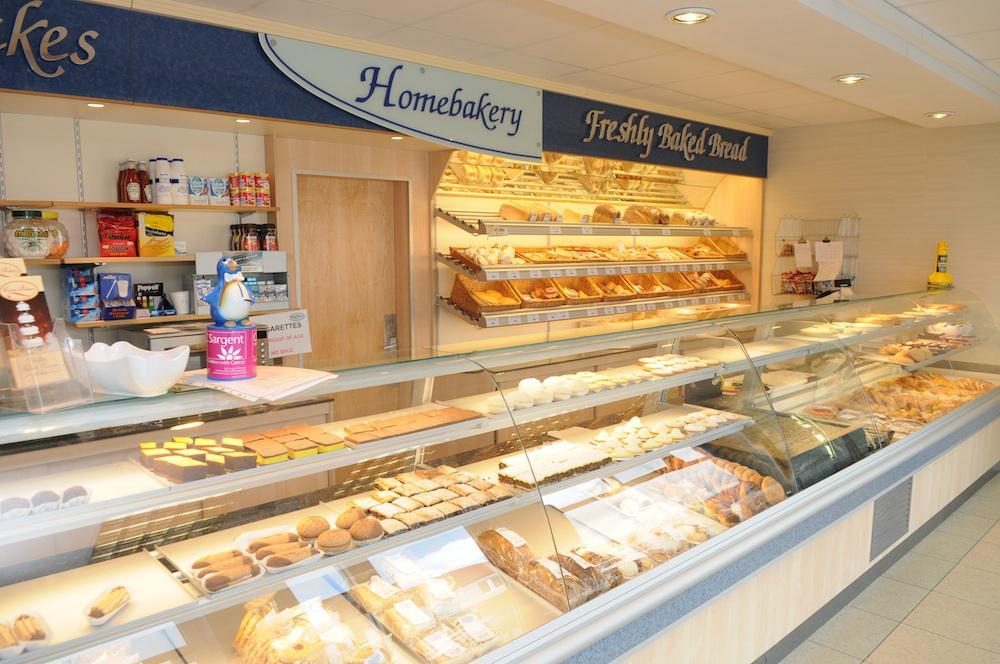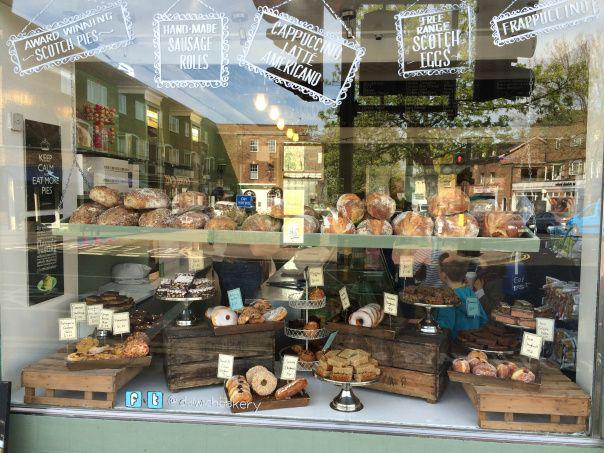The first image is the image on the left, the second image is the image on the right. Given the left and right images, does the statement "There are at least five hanging lights in the image on the right." hold true? Answer yes or no. Yes. 